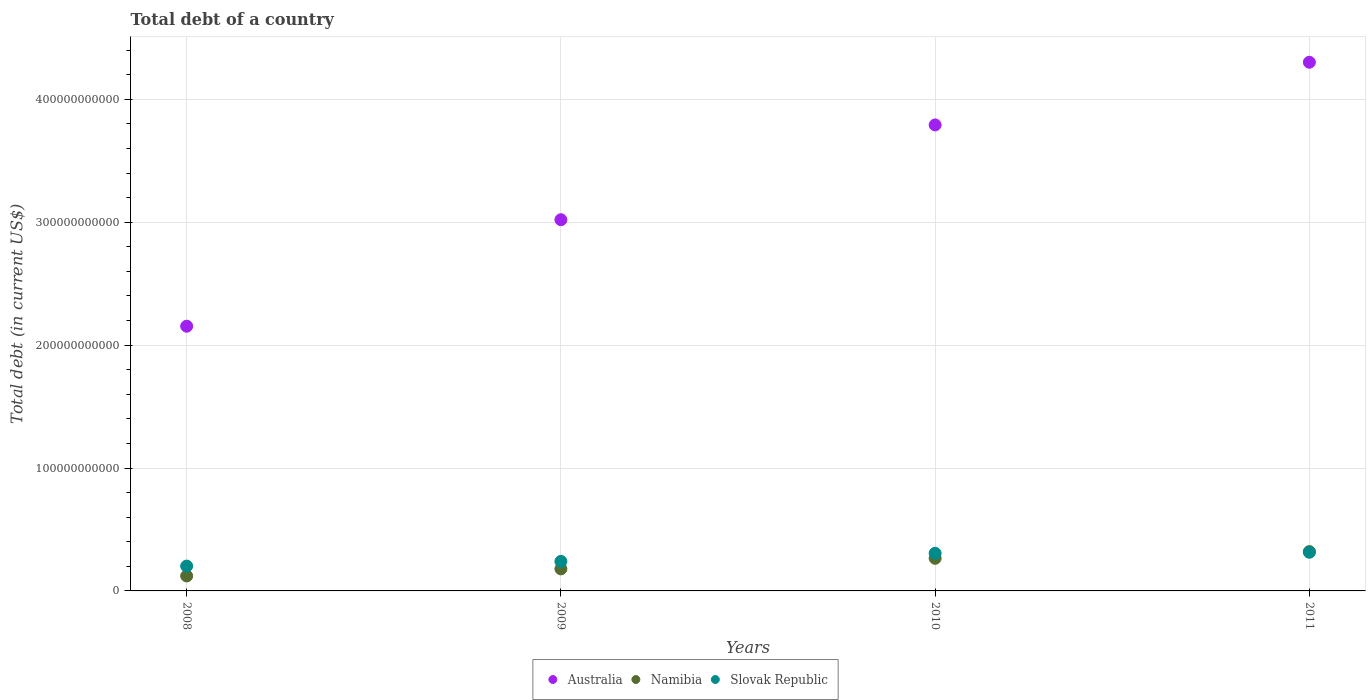How many different coloured dotlines are there?
Your answer should be compact. 3. What is the debt in Slovak Republic in 2008?
Provide a short and direct response. 2.02e+1. Across all years, what is the maximum debt in Australia?
Your response must be concise. 4.30e+11. Across all years, what is the minimum debt in Slovak Republic?
Offer a terse response. 2.02e+1. In which year was the debt in Slovak Republic minimum?
Keep it short and to the point. 2008. What is the total debt in Australia in the graph?
Keep it short and to the point. 1.33e+12. What is the difference between the debt in Australia in 2008 and that in 2011?
Your answer should be compact. -2.15e+11. What is the difference between the debt in Australia in 2011 and the debt in Slovak Republic in 2009?
Offer a terse response. 4.06e+11. What is the average debt in Namibia per year?
Provide a short and direct response. 2.22e+1. In the year 2010, what is the difference between the debt in Slovak Republic and debt in Australia?
Provide a succinct answer. -3.49e+11. What is the ratio of the debt in Australia in 2009 to that in 2011?
Provide a succinct answer. 0.7. What is the difference between the highest and the second highest debt in Slovak Republic?
Give a very brief answer. 8.50e+08. What is the difference between the highest and the lowest debt in Slovak Republic?
Offer a terse response. 1.12e+1. In how many years, is the debt in Namibia greater than the average debt in Namibia taken over all years?
Offer a terse response. 2. Is the sum of the debt in Slovak Republic in 2009 and 2011 greater than the maximum debt in Namibia across all years?
Give a very brief answer. Yes. Is it the case that in every year, the sum of the debt in Namibia and debt in Slovak Republic  is greater than the debt in Australia?
Provide a short and direct response. No. Is the debt in Slovak Republic strictly less than the debt in Australia over the years?
Give a very brief answer. Yes. How many dotlines are there?
Your answer should be very brief. 3. How many years are there in the graph?
Offer a very short reply. 4. What is the difference between two consecutive major ticks on the Y-axis?
Provide a short and direct response. 1.00e+11. Are the values on the major ticks of Y-axis written in scientific E-notation?
Your answer should be compact. No. Does the graph contain grids?
Provide a succinct answer. Yes. How many legend labels are there?
Give a very brief answer. 3. How are the legend labels stacked?
Give a very brief answer. Horizontal. What is the title of the graph?
Make the answer very short. Total debt of a country. Does "Hungary" appear as one of the legend labels in the graph?
Offer a terse response. No. What is the label or title of the X-axis?
Provide a succinct answer. Years. What is the label or title of the Y-axis?
Make the answer very short. Total debt (in current US$). What is the Total debt (in current US$) in Australia in 2008?
Your response must be concise. 2.15e+11. What is the Total debt (in current US$) in Namibia in 2008?
Your answer should be compact. 1.22e+1. What is the Total debt (in current US$) in Slovak Republic in 2008?
Provide a succinct answer. 2.02e+1. What is the Total debt (in current US$) of Australia in 2009?
Your answer should be very brief. 3.02e+11. What is the Total debt (in current US$) in Namibia in 2009?
Offer a very short reply. 1.79e+1. What is the Total debt (in current US$) in Slovak Republic in 2009?
Your response must be concise. 2.40e+1. What is the Total debt (in current US$) of Australia in 2010?
Offer a very short reply. 3.79e+11. What is the Total debt (in current US$) in Namibia in 2010?
Your answer should be very brief. 2.65e+1. What is the Total debt (in current US$) in Slovak Republic in 2010?
Offer a terse response. 3.06e+1. What is the Total debt (in current US$) of Australia in 2011?
Ensure brevity in your answer.  4.30e+11. What is the Total debt (in current US$) in Namibia in 2011?
Offer a very short reply. 3.20e+1. What is the Total debt (in current US$) of Slovak Republic in 2011?
Your answer should be very brief. 3.15e+1. Across all years, what is the maximum Total debt (in current US$) in Australia?
Keep it short and to the point. 4.30e+11. Across all years, what is the maximum Total debt (in current US$) of Namibia?
Ensure brevity in your answer.  3.20e+1. Across all years, what is the maximum Total debt (in current US$) of Slovak Republic?
Make the answer very short. 3.15e+1. Across all years, what is the minimum Total debt (in current US$) of Australia?
Offer a very short reply. 2.15e+11. Across all years, what is the minimum Total debt (in current US$) in Namibia?
Offer a very short reply. 1.22e+1. Across all years, what is the minimum Total debt (in current US$) of Slovak Republic?
Make the answer very short. 2.02e+1. What is the total Total debt (in current US$) of Australia in the graph?
Offer a terse response. 1.33e+12. What is the total Total debt (in current US$) of Namibia in the graph?
Provide a succinct answer. 8.87e+1. What is the total Total debt (in current US$) in Slovak Republic in the graph?
Give a very brief answer. 1.06e+11. What is the difference between the Total debt (in current US$) in Australia in 2008 and that in 2009?
Offer a terse response. -8.67e+1. What is the difference between the Total debt (in current US$) of Namibia in 2008 and that in 2009?
Your answer should be very brief. -5.77e+09. What is the difference between the Total debt (in current US$) of Slovak Republic in 2008 and that in 2009?
Make the answer very short. -3.80e+09. What is the difference between the Total debt (in current US$) in Australia in 2008 and that in 2010?
Give a very brief answer. -1.64e+11. What is the difference between the Total debt (in current US$) in Namibia in 2008 and that in 2010?
Provide a short and direct response. -1.44e+1. What is the difference between the Total debt (in current US$) in Slovak Republic in 2008 and that in 2010?
Make the answer very short. -1.04e+1. What is the difference between the Total debt (in current US$) in Australia in 2008 and that in 2011?
Provide a succinct answer. -2.15e+11. What is the difference between the Total debt (in current US$) in Namibia in 2008 and that in 2011?
Offer a terse response. -1.98e+1. What is the difference between the Total debt (in current US$) of Slovak Republic in 2008 and that in 2011?
Your response must be concise. -1.12e+1. What is the difference between the Total debt (in current US$) in Australia in 2009 and that in 2010?
Provide a succinct answer. -7.71e+1. What is the difference between the Total debt (in current US$) in Namibia in 2009 and that in 2010?
Provide a succinct answer. -8.60e+09. What is the difference between the Total debt (in current US$) of Slovak Republic in 2009 and that in 2010?
Offer a terse response. -6.59e+09. What is the difference between the Total debt (in current US$) in Australia in 2009 and that in 2011?
Your answer should be very brief. -1.28e+11. What is the difference between the Total debt (in current US$) of Namibia in 2009 and that in 2011?
Your response must be concise. -1.41e+1. What is the difference between the Total debt (in current US$) of Slovak Republic in 2009 and that in 2011?
Make the answer very short. -7.44e+09. What is the difference between the Total debt (in current US$) in Australia in 2010 and that in 2011?
Your response must be concise. -5.10e+1. What is the difference between the Total debt (in current US$) in Namibia in 2010 and that in 2011?
Offer a very short reply. -5.48e+09. What is the difference between the Total debt (in current US$) in Slovak Republic in 2010 and that in 2011?
Provide a short and direct response. -8.50e+08. What is the difference between the Total debt (in current US$) in Australia in 2008 and the Total debt (in current US$) in Namibia in 2009?
Keep it short and to the point. 1.97e+11. What is the difference between the Total debt (in current US$) in Australia in 2008 and the Total debt (in current US$) in Slovak Republic in 2009?
Provide a succinct answer. 1.91e+11. What is the difference between the Total debt (in current US$) of Namibia in 2008 and the Total debt (in current US$) of Slovak Republic in 2009?
Offer a very short reply. -1.18e+1. What is the difference between the Total debt (in current US$) of Australia in 2008 and the Total debt (in current US$) of Namibia in 2010?
Offer a very short reply. 1.89e+11. What is the difference between the Total debt (in current US$) of Australia in 2008 and the Total debt (in current US$) of Slovak Republic in 2010?
Offer a terse response. 1.85e+11. What is the difference between the Total debt (in current US$) of Namibia in 2008 and the Total debt (in current US$) of Slovak Republic in 2010?
Give a very brief answer. -1.84e+1. What is the difference between the Total debt (in current US$) in Australia in 2008 and the Total debt (in current US$) in Namibia in 2011?
Keep it short and to the point. 1.83e+11. What is the difference between the Total debt (in current US$) in Australia in 2008 and the Total debt (in current US$) in Slovak Republic in 2011?
Provide a succinct answer. 1.84e+11. What is the difference between the Total debt (in current US$) in Namibia in 2008 and the Total debt (in current US$) in Slovak Republic in 2011?
Give a very brief answer. -1.93e+1. What is the difference between the Total debt (in current US$) in Australia in 2009 and the Total debt (in current US$) in Namibia in 2010?
Your answer should be very brief. 2.76e+11. What is the difference between the Total debt (in current US$) in Australia in 2009 and the Total debt (in current US$) in Slovak Republic in 2010?
Provide a short and direct response. 2.71e+11. What is the difference between the Total debt (in current US$) of Namibia in 2009 and the Total debt (in current US$) of Slovak Republic in 2010?
Provide a succinct answer. -1.27e+1. What is the difference between the Total debt (in current US$) in Australia in 2009 and the Total debt (in current US$) in Namibia in 2011?
Your response must be concise. 2.70e+11. What is the difference between the Total debt (in current US$) of Australia in 2009 and the Total debt (in current US$) of Slovak Republic in 2011?
Offer a very short reply. 2.71e+11. What is the difference between the Total debt (in current US$) of Namibia in 2009 and the Total debt (in current US$) of Slovak Republic in 2011?
Offer a terse response. -1.35e+1. What is the difference between the Total debt (in current US$) of Australia in 2010 and the Total debt (in current US$) of Namibia in 2011?
Provide a succinct answer. 3.47e+11. What is the difference between the Total debt (in current US$) of Australia in 2010 and the Total debt (in current US$) of Slovak Republic in 2011?
Your answer should be very brief. 3.48e+11. What is the difference between the Total debt (in current US$) of Namibia in 2010 and the Total debt (in current US$) of Slovak Republic in 2011?
Keep it short and to the point. -4.92e+09. What is the average Total debt (in current US$) in Australia per year?
Offer a very short reply. 3.32e+11. What is the average Total debt (in current US$) of Namibia per year?
Your answer should be compact. 2.22e+1. What is the average Total debt (in current US$) in Slovak Republic per year?
Your answer should be compact. 2.66e+1. In the year 2008, what is the difference between the Total debt (in current US$) of Australia and Total debt (in current US$) of Namibia?
Your response must be concise. 2.03e+11. In the year 2008, what is the difference between the Total debt (in current US$) in Australia and Total debt (in current US$) in Slovak Republic?
Give a very brief answer. 1.95e+11. In the year 2008, what is the difference between the Total debt (in current US$) of Namibia and Total debt (in current US$) of Slovak Republic?
Your answer should be very brief. -8.04e+09. In the year 2009, what is the difference between the Total debt (in current US$) in Australia and Total debt (in current US$) in Namibia?
Offer a terse response. 2.84e+11. In the year 2009, what is the difference between the Total debt (in current US$) of Australia and Total debt (in current US$) of Slovak Republic?
Provide a succinct answer. 2.78e+11. In the year 2009, what is the difference between the Total debt (in current US$) in Namibia and Total debt (in current US$) in Slovak Republic?
Offer a very short reply. -6.07e+09. In the year 2010, what is the difference between the Total debt (in current US$) in Australia and Total debt (in current US$) in Namibia?
Keep it short and to the point. 3.53e+11. In the year 2010, what is the difference between the Total debt (in current US$) of Australia and Total debt (in current US$) of Slovak Republic?
Offer a terse response. 3.49e+11. In the year 2010, what is the difference between the Total debt (in current US$) in Namibia and Total debt (in current US$) in Slovak Republic?
Your answer should be very brief. -4.07e+09. In the year 2011, what is the difference between the Total debt (in current US$) in Australia and Total debt (in current US$) in Namibia?
Make the answer very short. 3.98e+11. In the year 2011, what is the difference between the Total debt (in current US$) in Australia and Total debt (in current US$) in Slovak Republic?
Your response must be concise. 3.99e+11. In the year 2011, what is the difference between the Total debt (in current US$) in Namibia and Total debt (in current US$) in Slovak Republic?
Keep it short and to the point. 5.61e+08. What is the ratio of the Total debt (in current US$) of Australia in 2008 to that in 2009?
Offer a very short reply. 0.71. What is the ratio of the Total debt (in current US$) in Namibia in 2008 to that in 2009?
Provide a short and direct response. 0.68. What is the ratio of the Total debt (in current US$) in Slovak Republic in 2008 to that in 2009?
Offer a very short reply. 0.84. What is the ratio of the Total debt (in current US$) in Australia in 2008 to that in 2010?
Offer a very short reply. 0.57. What is the ratio of the Total debt (in current US$) in Namibia in 2008 to that in 2010?
Provide a succinct answer. 0.46. What is the ratio of the Total debt (in current US$) of Slovak Republic in 2008 to that in 2010?
Provide a short and direct response. 0.66. What is the ratio of the Total debt (in current US$) of Australia in 2008 to that in 2011?
Provide a short and direct response. 0.5. What is the ratio of the Total debt (in current US$) of Namibia in 2008 to that in 2011?
Your answer should be compact. 0.38. What is the ratio of the Total debt (in current US$) in Slovak Republic in 2008 to that in 2011?
Ensure brevity in your answer.  0.64. What is the ratio of the Total debt (in current US$) in Australia in 2009 to that in 2010?
Give a very brief answer. 0.8. What is the ratio of the Total debt (in current US$) in Namibia in 2009 to that in 2010?
Make the answer very short. 0.68. What is the ratio of the Total debt (in current US$) of Slovak Republic in 2009 to that in 2010?
Offer a terse response. 0.78. What is the ratio of the Total debt (in current US$) of Australia in 2009 to that in 2011?
Ensure brevity in your answer.  0.7. What is the ratio of the Total debt (in current US$) in Namibia in 2009 to that in 2011?
Your answer should be very brief. 0.56. What is the ratio of the Total debt (in current US$) of Slovak Republic in 2009 to that in 2011?
Ensure brevity in your answer.  0.76. What is the ratio of the Total debt (in current US$) in Australia in 2010 to that in 2011?
Offer a very short reply. 0.88. What is the ratio of the Total debt (in current US$) in Namibia in 2010 to that in 2011?
Your answer should be very brief. 0.83. What is the ratio of the Total debt (in current US$) of Slovak Republic in 2010 to that in 2011?
Offer a very short reply. 0.97. What is the difference between the highest and the second highest Total debt (in current US$) of Australia?
Make the answer very short. 5.10e+1. What is the difference between the highest and the second highest Total debt (in current US$) in Namibia?
Keep it short and to the point. 5.48e+09. What is the difference between the highest and the second highest Total debt (in current US$) of Slovak Republic?
Provide a succinct answer. 8.50e+08. What is the difference between the highest and the lowest Total debt (in current US$) of Australia?
Keep it short and to the point. 2.15e+11. What is the difference between the highest and the lowest Total debt (in current US$) of Namibia?
Your answer should be very brief. 1.98e+1. What is the difference between the highest and the lowest Total debt (in current US$) in Slovak Republic?
Offer a very short reply. 1.12e+1. 